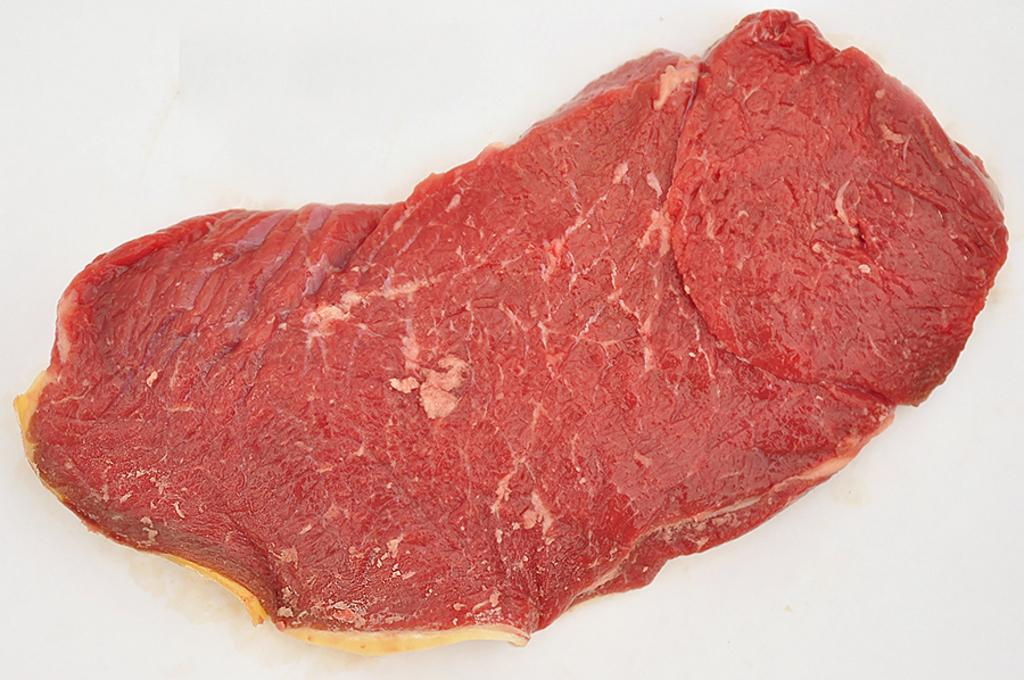What is the main subject of the image? The main subject of the image is a piece of flesh. What type of cream is being used by the governor during the war in the image? There is no governor, war, or cream present in the image; it only features a piece of flesh. 